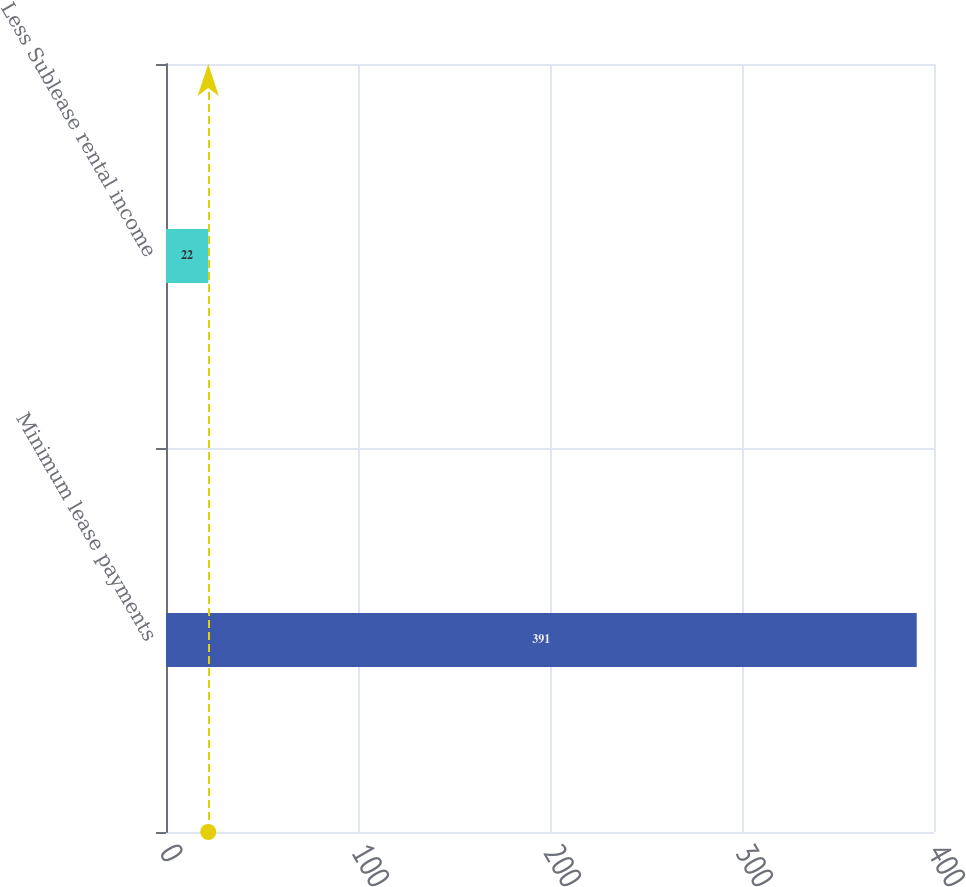Convert chart. <chart><loc_0><loc_0><loc_500><loc_500><bar_chart><fcel>Minimum lease payments<fcel>Less Sublease rental income<nl><fcel>391<fcel>22<nl></chart> 